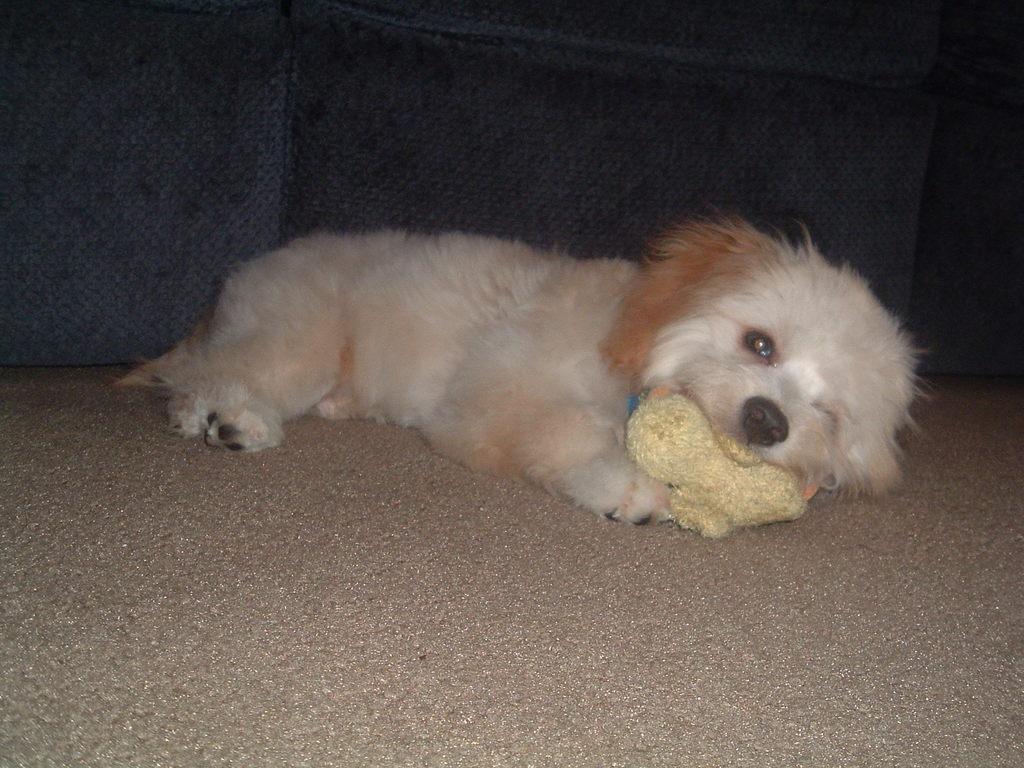Can you describe this image briefly? In this image there is a dog on a sofa. 